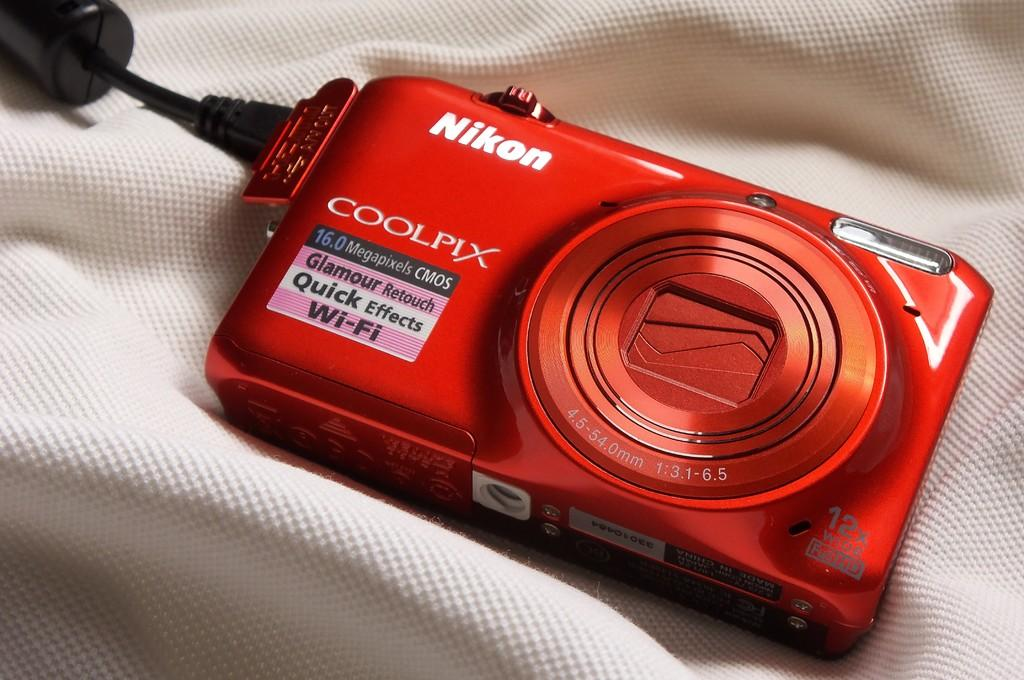What object is the main subject of the image? There is a camera in the image. What color is the camera? The camera is red in color. What is the background of the image? The camera is on a white background. What else can be seen on the left side of the image? There is a black cable on the left side of the image. Are there any toys visible in the image? No, there are no toys present in the image. Can you see a ghost in the image? No, there is no ghost visible in the image. 